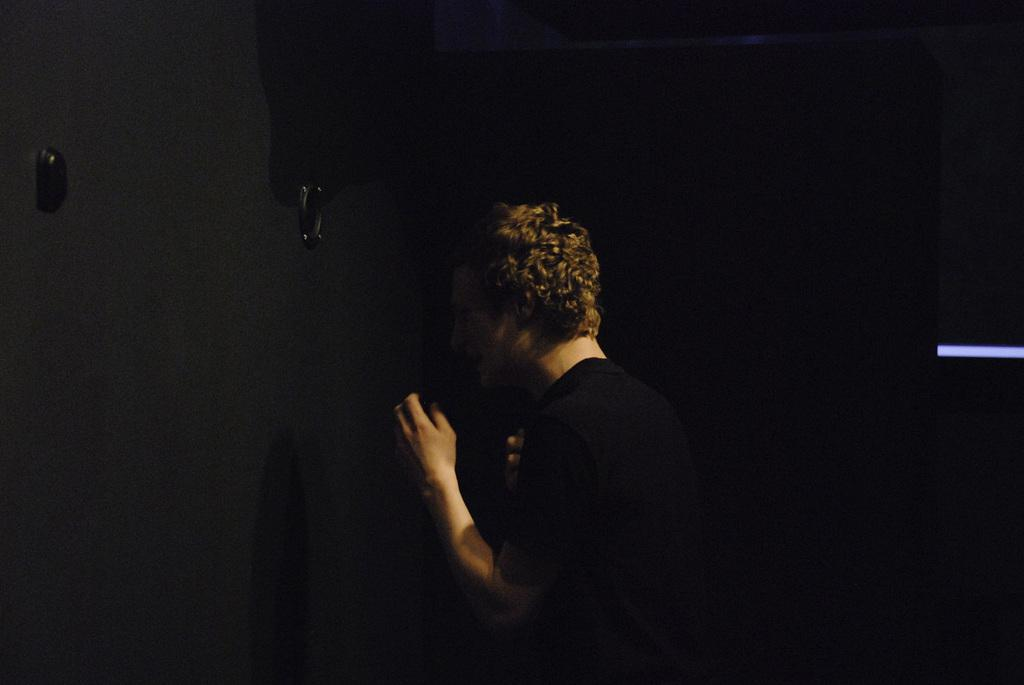What is the lighting condition in the image? The image is taken in a dark environment. Can you describe the person in the image? There is a person in the image. What is the person wearing in the image? The person is wearing a black dress. What type of jewel can be seen on the person's forehead in the image? There is no jewel visible on the person's forehead in the image. What is the reaction of the beetle to the person's presence in the image? There is no beetle present in the image, so it cannot react to the person's presence. 